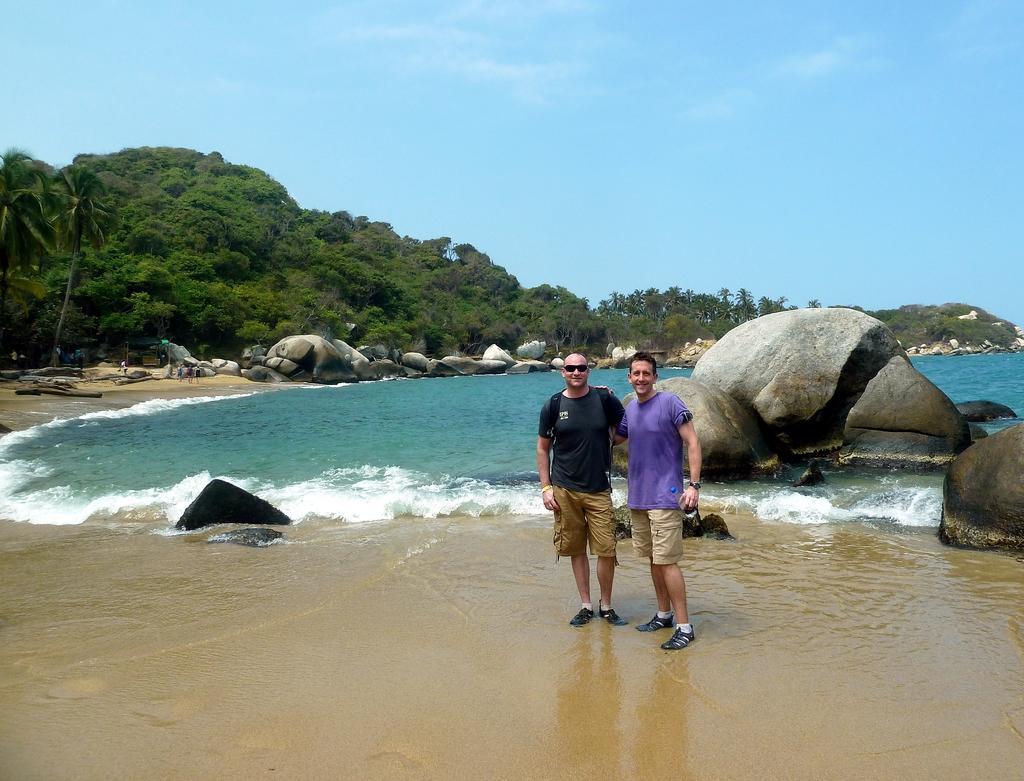In one or two sentences, can you explain what this image depicts? In this image we can see two persons are standing on the sand, he is wearing the glasses, at the back there are rocks, here is the water, there are trees, at above here is the sky. 